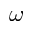<formula> <loc_0><loc_0><loc_500><loc_500>\omega</formula> 